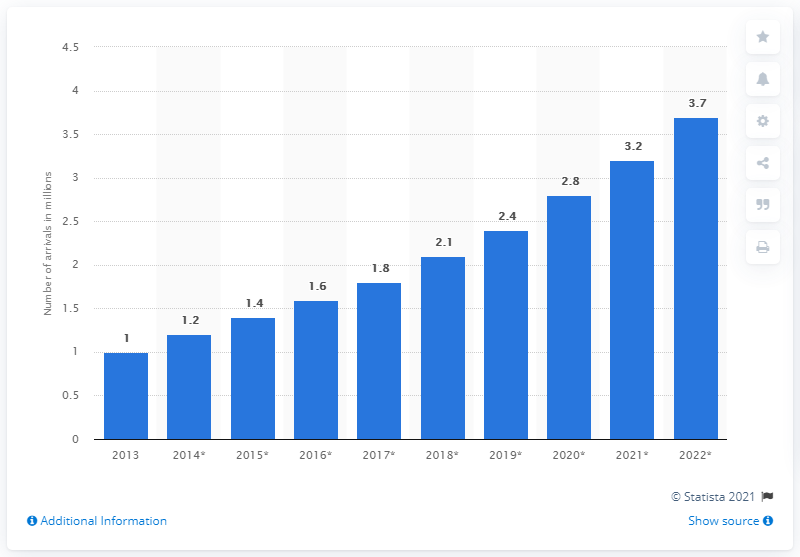Outline some significant characteristics in this image. By 2022, Qatar's forecast number of inbound tourists was expected to reach 3.7 million. 